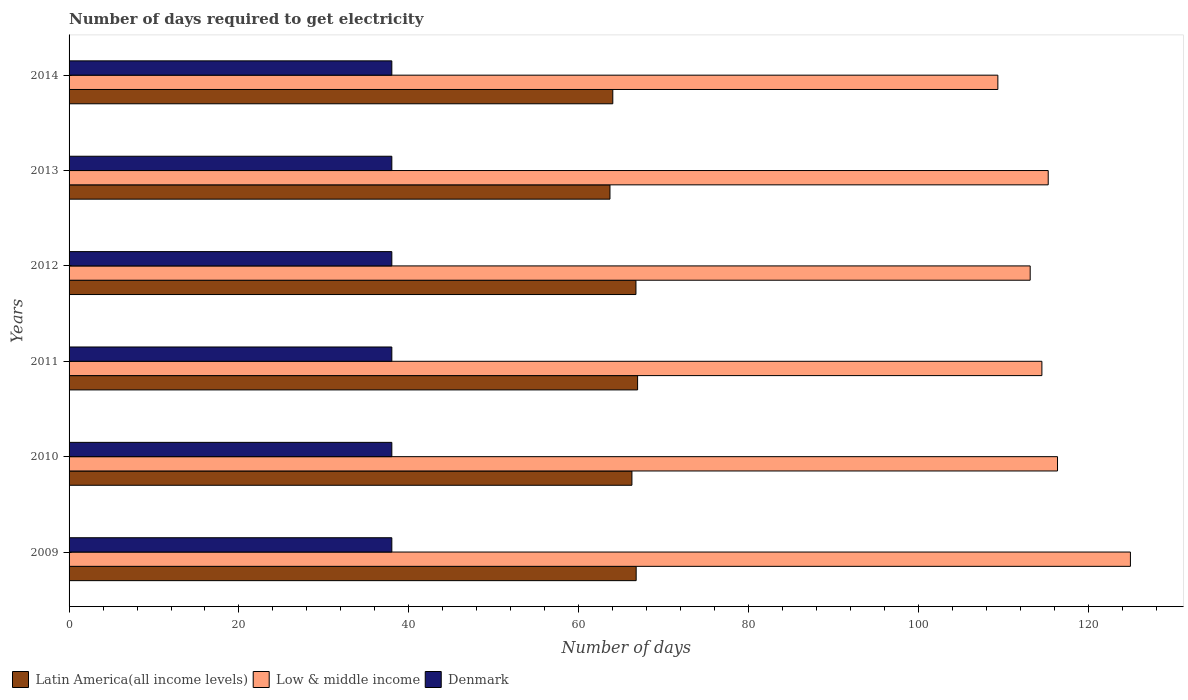How many different coloured bars are there?
Provide a succinct answer. 3. How many groups of bars are there?
Provide a short and direct response. 6. Are the number of bars per tick equal to the number of legend labels?
Ensure brevity in your answer.  Yes. Are the number of bars on each tick of the Y-axis equal?
Your answer should be compact. Yes. How many bars are there on the 4th tick from the top?
Keep it short and to the point. 3. What is the label of the 4th group of bars from the top?
Offer a very short reply. 2011. In how many cases, is the number of bars for a given year not equal to the number of legend labels?
Give a very brief answer. 0. What is the number of days required to get electricity in in Denmark in 2009?
Give a very brief answer. 38. Across all years, what is the maximum number of days required to get electricity in in Low & middle income?
Make the answer very short. 124.96. Across all years, what is the minimum number of days required to get electricity in in Denmark?
Offer a very short reply. 38. What is the total number of days required to get electricity in in Low & middle income in the graph?
Your answer should be compact. 693.65. What is the difference between the number of days required to get electricity in in Low & middle income in 2009 and that in 2014?
Make the answer very short. 15.61. What is the difference between the number of days required to get electricity in in Denmark in 2011 and the number of days required to get electricity in in Latin America(all income levels) in 2013?
Your response must be concise. -25.68. What is the average number of days required to get electricity in in Low & middle income per year?
Your answer should be compact. 115.61. In the year 2012, what is the difference between the number of days required to get electricity in in Latin America(all income levels) and number of days required to get electricity in in Denmark?
Make the answer very short. 28.74. What is the ratio of the number of days required to get electricity in in Latin America(all income levels) in 2010 to that in 2014?
Keep it short and to the point. 1.04. What is the difference between the highest and the second highest number of days required to get electricity in in Low & middle income?
Your answer should be very brief. 8.58. What is the difference between the highest and the lowest number of days required to get electricity in in Denmark?
Provide a succinct answer. 0. In how many years, is the number of days required to get electricity in in Low & middle income greater than the average number of days required to get electricity in in Low & middle income taken over all years?
Your answer should be very brief. 2. Is the sum of the number of days required to get electricity in in Latin America(all income levels) in 2009 and 2010 greater than the maximum number of days required to get electricity in in Denmark across all years?
Your answer should be compact. Yes. What does the 3rd bar from the top in 2009 represents?
Provide a short and direct response. Latin America(all income levels). What does the 3rd bar from the bottom in 2014 represents?
Give a very brief answer. Denmark. Does the graph contain grids?
Ensure brevity in your answer.  No. How are the legend labels stacked?
Keep it short and to the point. Horizontal. What is the title of the graph?
Provide a succinct answer. Number of days required to get electricity. Does "Liechtenstein" appear as one of the legend labels in the graph?
Make the answer very short. No. What is the label or title of the X-axis?
Give a very brief answer. Number of days. What is the Number of days in Latin America(all income levels) in 2009?
Make the answer very short. 66.77. What is the Number of days in Low & middle income in 2009?
Keep it short and to the point. 124.96. What is the Number of days of Latin America(all income levels) in 2010?
Your answer should be compact. 66.27. What is the Number of days of Low & middle income in 2010?
Keep it short and to the point. 116.37. What is the Number of days in Denmark in 2010?
Your answer should be very brief. 38. What is the Number of days in Latin America(all income levels) in 2011?
Ensure brevity in your answer.  66.94. What is the Number of days in Low & middle income in 2011?
Provide a short and direct response. 114.53. What is the Number of days in Latin America(all income levels) in 2012?
Ensure brevity in your answer.  66.74. What is the Number of days in Low & middle income in 2012?
Your answer should be compact. 113.16. What is the Number of days in Latin America(all income levels) in 2013?
Offer a very short reply. 63.68. What is the Number of days in Low & middle income in 2013?
Make the answer very short. 115.28. What is the Number of days of Latin America(all income levels) in 2014?
Make the answer very short. 64.02. What is the Number of days of Low & middle income in 2014?
Make the answer very short. 109.35. Across all years, what is the maximum Number of days of Latin America(all income levels)?
Ensure brevity in your answer.  66.94. Across all years, what is the maximum Number of days of Low & middle income?
Provide a succinct answer. 124.96. Across all years, what is the minimum Number of days in Latin America(all income levels)?
Your answer should be very brief. 63.68. Across all years, what is the minimum Number of days in Low & middle income?
Offer a terse response. 109.35. What is the total Number of days in Latin America(all income levels) in the graph?
Provide a succinct answer. 394.41. What is the total Number of days of Low & middle income in the graph?
Offer a very short reply. 693.65. What is the total Number of days of Denmark in the graph?
Your answer should be very brief. 228. What is the difference between the Number of days in Low & middle income in 2009 and that in 2010?
Keep it short and to the point. 8.58. What is the difference between the Number of days in Denmark in 2009 and that in 2010?
Provide a succinct answer. 0. What is the difference between the Number of days of Latin America(all income levels) in 2009 and that in 2011?
Ensure brevity in your answer.  -0.17. What is the difference between the Number of days in Low & middle income in 2009 and that in 2011?
Your response must be concise. 10.42. What is the difference between the Number of days of Denmark in 2009 and that in 2011?
Your answer should be compact. 0. What is the difference between the Number of days in Latin America(all income levels) in 2009 and that in 2012?
Give a very brief answer. 0.02. What is the difference between the Number of days of Low & middle income in 2009 and that in 2012?
Give a very brief answer. 11.8. What is the difference between the Number of days in Denmark in 2009 and that in 2012?
Offer a very short reply. 0. What is the difference between the Number of days in Latin America(all income levels) in 2009 and that in 2013?
Your answer should be very brief. 3.08. What is the difference between the Number of days in Low & middle income in 2009 and that in 2013?
Offer a very short reply. 9.68. What is the difference between the Number of days in Denmark in 2009 and that in 2013?
Keep it short and to the point. 0. What is the difference between the Number of days of Latin America(all income levels) in 2009 and that in 2014?
Give a very brief answer. 2.75. What is the difference between the Number of days of Low & middle income in 2009 and that in 2014?
Your response must be concise. 15.61. What is the difference between the Number of days in Denmark in 2009 and that in 2014?
Give a very brief answer. 0. What is the difference between the Number of days in Latin America(all income levels) in 2010 and that in 2011?
Your response must be concise. -0.67. What is the difference between the Number of days in Low & middle income in 2010 and that in 2011?
Ensure brevity in your answer.  1.84. What is the difference between the Number of days in Latin America(all income levels) in 2010 and that in 2012?
Offer a terse response. -0.48. What is the difference between the Number of days in Low & middle income in 2010 and that in 2012?
Offer a terse response. 3.22. What is the difference between the Number of days in Latin America(all income levels) in 2010 and that in 2013?
Provide a succinct answer. 2.58. What is the difference between the Number of days of Low & middle income in 2010 and that in 2013?
Offer a terse response. 1.09. What is the difference between the Number of days in Denmark in 2010 and that in 2013?
Offer a terse response. 0. What is the difference between the Number of days of Latin America(all income levels) in 2010 and that in 2014?
Offer a terse response. 2.25. What is the difference between the Number of days of Low & middle income in 2010 and that in 2014?
Provide a short and direct response. 7.02. What is the difference between the Number of days of Latin America(all income levels) in 2011 and that in 2012?
Provide a succinct answer. 0.19. What is the difference between the Number of days of Low & middle income in 2011 and that in 2012?
Provide a short and direct response. 1.38. What is the difference between the Number of days of Latin America(all income levels) in 2011 and that in 2013?
Offer a terse response. 3.25. What is the difference between the Number of days in Low & middle income in 2011 and that in 2013?
Keep it short and to the point. -0.75. What is the difference between the Number of days of Latin America(all income levels) in 2011 and that in 2014?
Your response must be concise. 2.92. What is the difference between the Number of days in Low & middle income in 2011 and that in 2014?
Offer a very short reply. 5.18. What is the difference between the Number of days in Denmark in 2011 and that in 2014?
Provide a short and direct response. 0. What is the difference between the Number of days in Latin America(all income levels) in 2012 and that in 2013?
Your response must be concise. 3.06. What is the difference between the Number of days of Low & middle income in 2012 and that in 2013?
Give a very brief answer. -2.12. What is the difference between the Number of days of Latin America(all income levels) in 2012 and that in 2014?
Offer a very short reply. 2.73. What is the difference between the Number of days of Low & middle income in 2012 and that in 2014?
Ensure brevity in your answer.  3.81. What is the difference between the Number of days of Denmark in 2012 and that in 2014?
Offer a terse response. 0. What is the difference between the Number of days of Low & middle income in 2013 and that in 2014?
Give a very brief answer. 5.93. What is the difference between the Number of days of Denmark in 2013 and that in 2014?
Your answer should be very brief. 0. What is the difference between the Number of days in Latin America(all income levels) in 2009 and the Number of days in Low & middle income in 2010?
Your response must be concise. -49.61. What is the difference between the Number of days of Latin America(all income levels) in 2009 and the Number of days of Denmark in 2010?
Your answer should be compact. 28.77. What is the difference between the Number of days in Low & middle income in 2009 and the Number of days in Denmark in 2010?
Keep it short and to the point. 86.96. What is the difference between the Number of days in Latin America(all income levels) in 2009 and the Number of days in Low & middle income in 2011?
Your answer should be compact. -47.77. What is the difference between the Number of days in Latin America(all income levels) in 2009 and the Number of days in Denmark in 2011?
Offer a terse response. 28.77. What is the difference between the Number of days of Low & middle income in 2009 and the Number of days of Denmark in 2011?
Provide a succinct answer. 86.96. What is the difference between the Number of days in Latin America(all income levels) in 2009 and the Number of days in Low & middle income in 2012?
Your response must be concise. -46.39. What is the difference between the Number of days in Latin America(all income levels) in 2009 and the Number of days in Denmark in 2012?
Offer a terse response. 28.77. What is the difference between the Number of days in Low & middle income in 2009 and the Number of days in Denmark in 2012?
Make the answer very short. 86.96. What is the difference between the Number of days of Latin America(all income levels) in 2009 and the Number of days of Low & middle income in 2013?
Provide a short and direct response. -48.51. What is the difference between the Number of days in Latin America(all income levels) in 2009 and the Number of days in Denmark in 2013?
Your answer should be very brief. 28.77. What is the difference between the Number of days in Low & middle income in 2009 and the Number of days in Denmark in 2013?
Keep it short and to the point. 86.96. What is the difference between the Number of days in Latin America(all income levels) in 2009 and the Number of days in Low & middle income in 2014?
Give a very brief answer. -42.58. What is the difference between the Number of days of Latin America(all income levels) in 2009 and the Number of days of Denmark in 2014?
Ensure brevity in your answer.  28.77. What is the difference between the Number of days in Low & middle income in 2009 and the Number of days in Denmark in 2014?
Keep it short and to the point. 86.96. What is the difference between the Number of days in Latin America(all income levels) in 2010 and the Number of days in Low & middle income in 2011?
Keep it short and to the point. -48.27. What is the difference between the Number of days in Latin America(all income levels) in 2010 and the Number of days in Denmark in 2011?
Your answer should be compact. 28.27. What is the difference between the Number of days of Low & middle income in 2010 and the Number of days of Denmark in 2011?
Your answer should be compact. 78.37. What is the difference between the Number of days in Latin America(all income levels) in 2010 and the Number of days in Low & middle income in 2012?
Offer a very short reply. -46.89. What is the difference between the Number of days of Latin America(all income levels) in 2010 and the Number of days of Denmark in 2012?
Give a very brief answer. 28.27. What is the difference between the Number of days in Low & middle income in 2010 and the Number of days in Denmark in 2012?
Ensure brevity in your answer.  78.37. What is the difference between the Number of days of Latin America(all income levels) in 2010 and the Number of days of Low & middle income in 2013?
Your answer should be very brief. -49.01. What is the difference between the Number of days of Latin America(all income levels) in 2010 and the Number of days of Denmark in 2013?
Your answer should be very brief. 28.27. What is the difference between the Number of days in Low & middle income in 2010 and the Number of days in Denmark in 2013?
Keep it short and to the point. 78.37. What is the difference between the Number of days in Latin America(all income levels) in 2010 and the Number of days in Low & middle income in 2014?
Provide a succinct answer. -43.08. What is the difference between the Number of days in Latin America(all income levels) in 2010 and the Number of days in Denmark in 2014?
Your answer should be compact. 28.27. What is the difference between the Number of days in Low & middle income in 2010 and the Number of days in Denmark in 2014?
Keep it short and to the point. 78.37. What is the difference between the Number of days of Latin America(all income levels) in 2011 and the Number of days of Low & middle income in 2012?
Provide a succinct answer. -46.22. What is the difference between the Number of days of Latin America(all income levels) in 2011 and the Number of days of Denmark in 2012?
Offer a very short reply. 28.94. What is the difference between the Number of days in Low & middle income in 2011 and the Number of days in Denmark in 2012?
Provide a short and direct response. 76.53. What is the difference between the Number of days of Latin America(all income levels) in 2011 and the Number of days of Low & middle income in 2013?
Offer a very short reply. -48.34. What is the difference between the Number of days in Latin America(all income levels) in 2011 and the Number of days in Denmark in 2013?
Your answer should be compact. 28.94. What is the difference between the Number of days in Low & middle income in 2011 and the Number of days in Denmark in 2013?
Your response must be concise. 76.53. What is the difference between the Number of days of Latin America(all income levels) in 2011 and the Number of days of Low & middle income in 2014?
Offer a terse response. -42.41. What is the difference between the Number of days in Latin America(all income levels) in 2011 and the Number of days in Denmark in 2014?
Ensure brevity in your answer.  28.94. What is the difference between the Number of days in Low & middle income in 2011 and the Number of days in Denmark in 2014?
Ensure brevity in your answer.  76.53. What is the difference between the Number of days in Latin America(all income levels) in 2012 and the Number of days in Low & middle income in 2013?
Make the answer very short. -48.54. What is the difference between the Number of days in Latin America(all income levels) in 2012 and the Number of days in Denmark in 2013?
Offer a terse response. 28.74. What is the difference between the Number of days of Low & middle income in 2012 and the Number of days of Denmark in 2013?
Provide a short and direct response. 75.16. What is the difference between the Number of days in Latin America(all income levels) in 2012 and the Number of days in Low & middle income in 2014?
Offer a terse response. -42.61. What is the difference between the Number of days of Latin America(all income levels) in 2012 and the Number of days of Denmark in 2014?
Give a very brief answer. 28.74. What is the difference between the Number of days in Low & middle income in 2012 and the Number of days in Denmark in 2014?
Your answer should be very brief. 75.16. What is the difference between the Number of days in Latin America(all income levels) in 2013 and the Number of days in Low & middle income in 2014?
Provide a succinct answer. -45.67. What is the difference between the Number of days in Latin America(all income levels) in 2013 and the Number of days in Denmark in 2014?
Offer a very short reply. 25.68. What is the difference between the Number of days of Low & middle income in 2013 and the Number of days of Denmark in 2014?
Provide a short and direct response. 77.28. What is the average Number of days of Latin America(all income levels) per year?
Give a very brief answer. 65.73. What is the average Number of days in Low & middle income per year?
Keep it short and to the point. 115.61. In the year 2009, what is the difference between the Number of days in Latin America(all income levels) and Number of days in Low & middle income?
Provide a succinct answer. -58.19. In the year 2009, what is the difference between the Number of days of Latin America(all income levels) and Number of days of Denmark?
Give a very brief answer. 28.77. In the year 2009, what is the difference between the Number of days of Low & middle income and Number of days of Denmark?
Offer a very short reply. 86.96. In the year 2010, what is the difference between the Number of days in Latin America(all income levels) and Number of days in Low & middle income?
Make the answer very short. -50.11. In the year 2010, what is the difference between the Number of days in Latin America(all income levels) and Number of days in Denmark?
Give a very brief answer. 28.27. In the year 2010, what is the difference between the Number of days in Low & middle income and Number of days in Denmark?
Offer a terse response. 78.37. In the year 2011, what is the difference between the Number of days in Latin America(all income levels) and Number of days in Low & middle income?
Provide a succinct answer. -47.6. In the year 2011, what is the difference between the Number of days of Latin America(all income levels) and Number of days of Denmark?
Offer a terse response. 28.94. In the year 2011, what is the difference between the Number of days of Low & middle income and Number of days of Denmark?
Offer a terse response. 76.53. In the year 2012, what is the difference between the Number of days of Latin America(all income levels) and Number of days of Low & middle income?
Your answer should be very brief. -46.42. In the year 2012, what is the difference between the Number of days in Latin America(all income levels) and Number of days in Denmark?
Your answer should be very brief. 28.74. In the year 2012, what is the difference between the Number of days in Low & middle income and Number of days in Denmark?
Your answer should be compact. 75.16. In the year 2013, what is the difference between the Number of days in Latin America(all income levels) and Number of days in Low & middle income?
Offer a very short reply. -51.6. In the year 2013, what is the difference between the Number of days in Latin America(all income levels) and Number of days in Denmark?
Keep it short and to the point. 25.68. In the year 2013, what is the difference between the Number of days of Low & middle income and Number of days of Denmark?
Offer a very short reply. 77.28. In the year 2014, what is the difference between the Number of days in Latin America(all income levels) and Number of days in Low & middle income?
Your answer should be compact. -45.33. In the year 2014, what is the difference between the Number of days of Latin America(all income levels) and Number of days of Denmark?
Your response must be concise. 26.02. In the year 2014, what is the difference between the Number of days in Low & middle income and Number of days in Denmark?
Your answer should be very brief. 71.35. What is the ratio of the Number of days in Latin America(all income levels) in 2009 to that in 2010?
Your answer should be very brief. 1.01. What is the ratio of the Number of days in Low & middle income in 2009 to that in 2010?
Give a very brief answer. 1.07. What is the ratio of the Number of days of Low & middle income in 2009 to that in 2011?
Ensure brevity in your answer.  1.09. What is the ratio of the Number of days in Latin America(all income levels) in 2009 to that in 2012?
Keep it short and to the point. 1. What is the ratio of the Number of days of Low & middle income in 2009 to that in 2012?
Offer a very short reply. 1.1. What is the ratio of the Number of days in Denmark in 2009 to that in 2012?
Provide a succinct answer. 1. What is the ratio of the Number of days in Latin America(all income levels) in 2009 to that in 2013?
Your response must be concise. 1.05. What is the ratio of the Number of days in Low & middle income in 2009 to that in 2013?
Keep it short and to the point. 1.08. What is the ratio of the Number of days in Latin America(all income levels) in 2009 to that in 2014?
Give a very brief answer. 1.04. What is the ratio of the Number of days in Low & middle income in 2009 to that in 2014?
Make the answer very short. 1.14. What is the ratio of the Number of days of Latin America(all income levels) in 2010 to that in 2011?
Your answer should be very brief. 0.99. What is the ratio of the Number of days of Low & middle income in 2010 to that in 2011?
Offer a terse response. 1.02. What is the ratio of the Number of days of Denmark in 2010 to that in 2011?
Ensure brevity in your answer.  1. What is the ratio of the Number of days of Low & middle income in 2010 to that in 2012?
Make the answer very short. 1.03. What is the ratio of the Number of days of Denmark in 2010 to that in 2012?
Keep it short and to the point. 1. What is the ratio of the Number of days of Latin America(all income levels) in 2010 to that in 2013?
Offer a terse response. 1.04. What is the ratio of the Number of days in Low & middle income in 2010 to that in 2013?
Offer a terse response. 1.01. What is the ratio of the Number of days of Latin America(all income levels) in 2010 to that in 2014?
Your answer should be compact. 1.04. What is the ratio of the Number of days of Low & middle income in 2010 to that in 2014?
Ensure brevity in your answer.  1.06. What is the ratio of the Number of days of Low & middle income in 2011 to that in 2012?
Provide a short and direct response. 1.01. What is the ratio of the Number of days in Latin America(all income levels) in 2011 to that in 2013?
Ensure brevity in your answer.  1.05. What is the ratio of the Number of days in Latin America(all income levels) in 2011 to that in 2014?
Keep it short and to the point. 1.05. What is the ratio of the Number of days in Low & middle income in 2011 to that in 2014?
Your answer should be compact. 1.05. What is the ratio of the Number of days of Denmark in 2011 to that in 2014?
Provide a succinct answer. 1. What is the ratio of the Number of days of Latin America(all income levels) in 2012 to that in 2013?
Give a very brief answer. 1.05. What is the ratio of the Number of days of Low & middle income in 2012 to that in 2013?
Give a very brief answer. 0.98. What is the ratio of the Number of days in Latin America(all income levels) in 2012 to that in 2014?
Keep it short and to the point. 1.04. What is the ratio of the Number of days of Low & middle income in 2012 to that in 2014?
Provide a short and direct response. 1.03. What is the ratio of the Number of days of Denmark in 2012 to that in 2014?
Offer a terse response. 1. What is the ratio of the Number of days in Low & middle income in 2013 to that in 2014?
Your answer should be very brief. 1.05. What is the difference between the highest and the second highest Number of days in Latin America(all income levels)?
Provide a short and direct response. 0.17. What is the difference between the highest and the second highest Number of days in Low & middle income?
Make the answer very short. 8.58. What is the difference between the highest and the lowest Number of days in Latin America(all income levels)?
Ensure brevity in your answer.  3.25. What is the difference between the highest and the lowest Number of days of Low & middle income?
Offer a terse response. 15.61. What is the difference between the highest and the lowest Number of days in Denmark?
Provide a succinct answer. 0. 